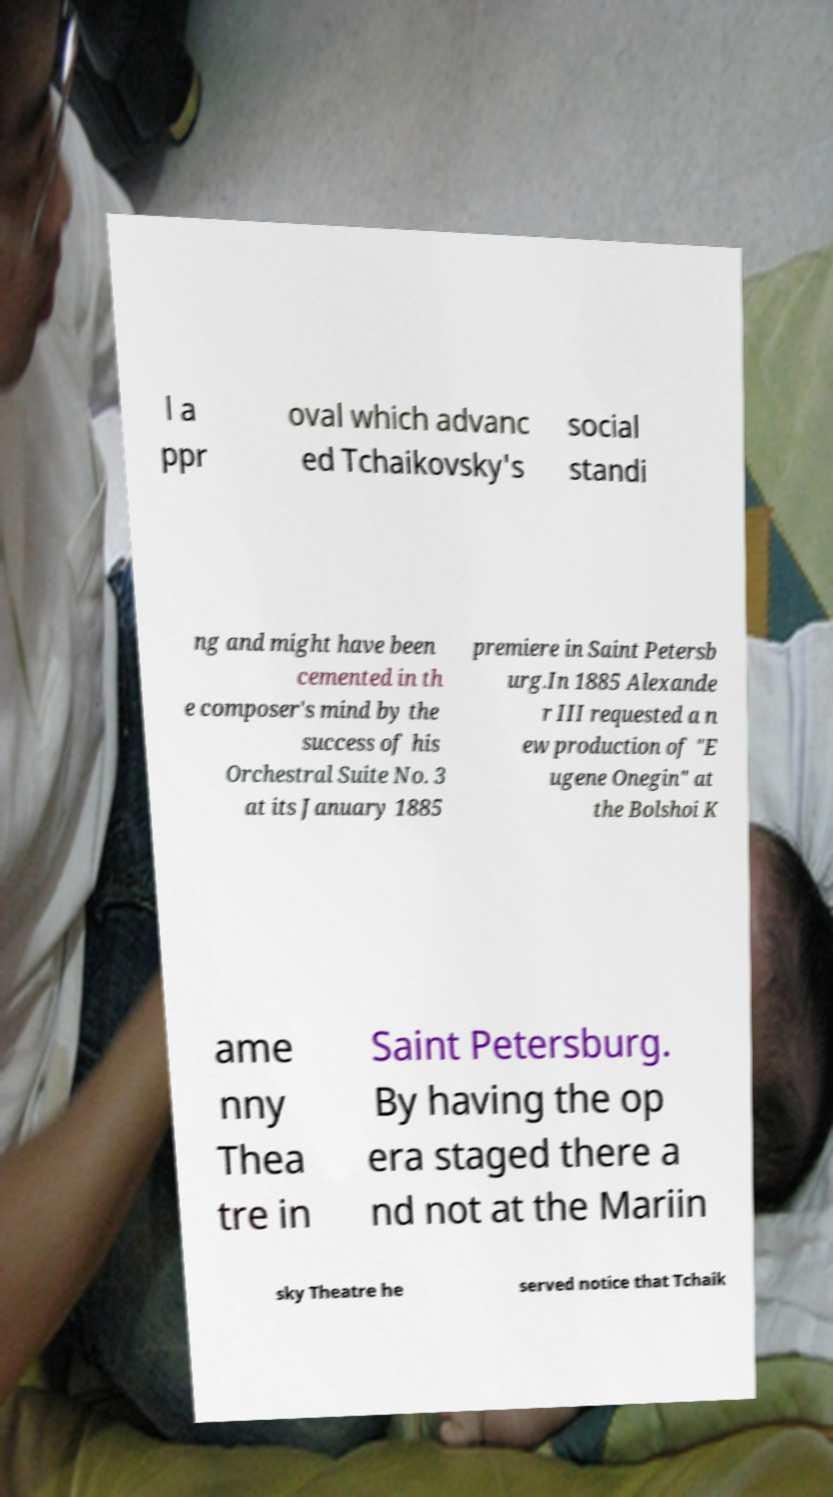There's text embedded in this image that I need extracted. Can you transcribe it verbatim? l a ppr oval which advanc ed Tchaikovsky's social standi ng and might have been cemented in th e composer's mind by the success of his Orchestral Suite No. 3 at its January 1885 premiere in Saint Petersb urg.In 1885 Alexande r III requested a n ew production of "E ugene Onegin" at the Bolshoi K ame nny Thea tre in Saint Petersburg. By having the op era staged there a nd not at the Mariin sky Theatre he served notice that Tchaik 